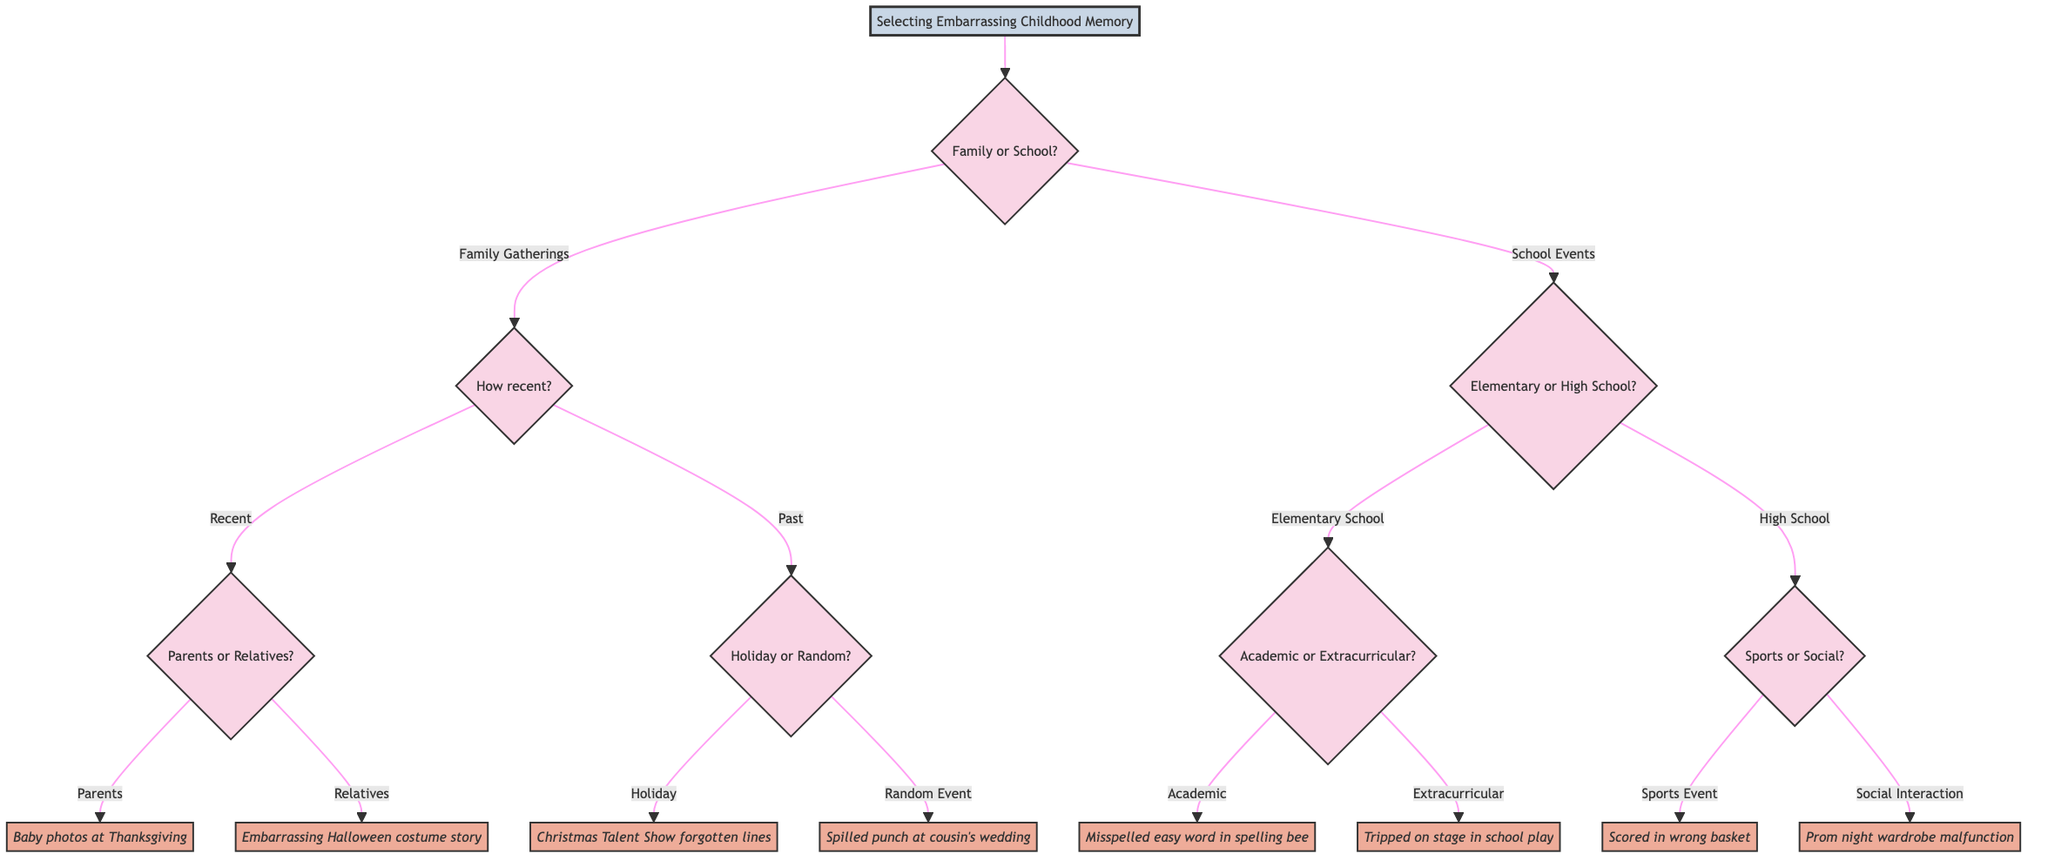What is the first decision point in the diagram? The first decision point is labeled "Family or School?" This is the first question that splits the flow into two main categories.
Answer: Family or School? How many total nodes are there in the diagram? The diagram has a total of 16 nodes, including the starting node and all subsections. Each decision and event is counted as a node.
Answer: 16 Which event corresponds to the choice of "Parents" in the family gatherings? The choice of "Parents" leads to the event "That time mom showed their baby photos during Thanksgiving." This is the specific event associated with that branch.
Answer: That time mom showed their baby photos during Thanksgiving What is the event for "High School" and "Social Interaction"? The combination of "High School" and "Social Interaction" leads to the event "Prom night story involving a wardrobe malfunction." This is the event reached by following the path through those specific choices.
Answer: Prom night story involving a wardrobe malfunction If someone chooses "Elementary School" and "Extracurricular," what memory will they get? Choosing "Elementary School" leads to a question about extracurricular activities. If "Extracurricular" is selected, the memory will be "The school play where they tripped on stage." This follows the path from the initial decision.
Answer: The school play where they tripped on stage What is the second decision point after selecting "Family Gatherings"? The second decision point after selecting "Family Gatherings" is "How recent should the memory be?" This question narrows down the choice further by time frame.
Answer: How recent should the memory be? Which event is associated with a "Random Event" from the past family gatherings? The "Random Event" from the past family gatherings corresponds to the memory "Cousin's wedding where they spilled punch on their outfit." This captures an embarrassing incident at a family event.
Answer: Cousin's wedding where they spilled punch on their outfit What happens if you select "Sports Event" under "High School"? Selecting "Sports Event" under "High School" leads directly to the event "The basketball game where they scored in the wrong basket." This is an embarrassing moment in the context of sports at high school.
Answer: The basketball game where they scored in the wrong basket 